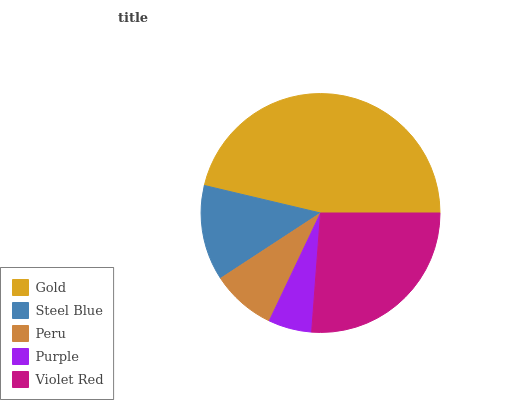Is Purple the minimum?
Answer yes or no. Yes. Is Gold the maximum?
Answer yes or no. Yes. Is Steel Blue the minimum?
Answer yes or no. No. Is Steel Blue the maximum?
Answer yes or no. No. Is Gold greater than Steel Blue?
Answer yes or no. Yes. Is Steel Blue less than Gold?
Answer yes or no. Yes. Is Steel Blue greater than Gold?
Answer yes or no. No. Is Gold less than Steel Blue?
Answer yes or no. No. Is Steel Blue the high median?
Answer yes or no. Yes. Is Steel Blue the low median?
Answer yes or no. Yes. Is Purple the high median?
Answer yes or no. No. Is Gold the low median?
Answer yes or no. No. 